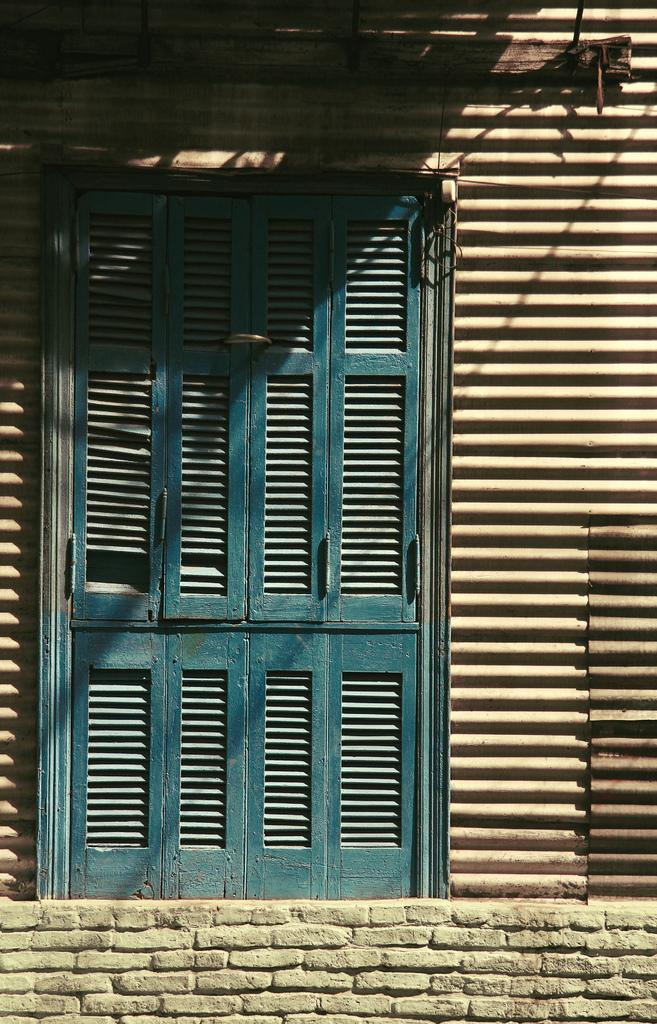What is a prominent feature in the image? There is a wall in the image. Can you describe any openings in the wall? Yes, there are windows in the image. What type of distribution system is visible in the image? There is no distribution system present in the image; it only features a wall and windows. What kind of steel is used to construct the windows in the image? The image does not provide information about the type of steel used in the windows, nor does it show any steel. 